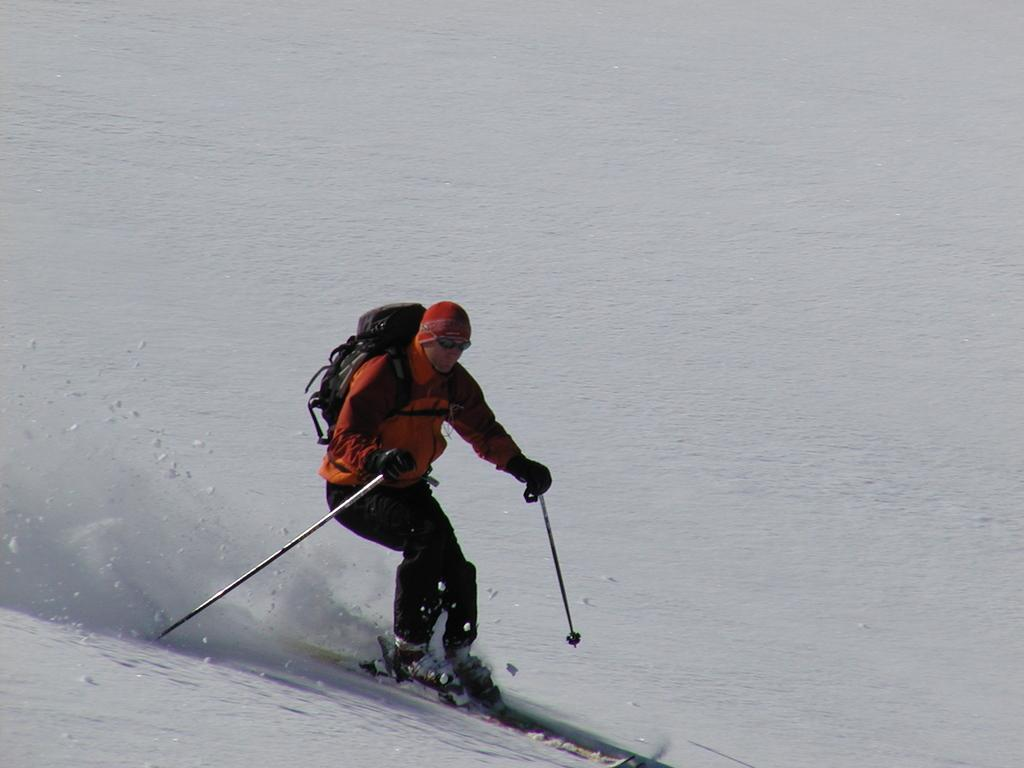What is the main subject of the image? The main subject of the image is a man. What activity is the man engaged in? The man is skiing on the snow. Where is the man located in the image? The man is in the center of the image. What additional item is the man wearing? The man is wearing a backpack. What type of question is the man asking in the image? There is no indication in the image that the man is asking a question. Is the man writing anything in the image? There is no indication in the image that the man is writing anything. What is the man doing with his mouth in the image? There is no indication in the image of what the man is doing with his mouth. 